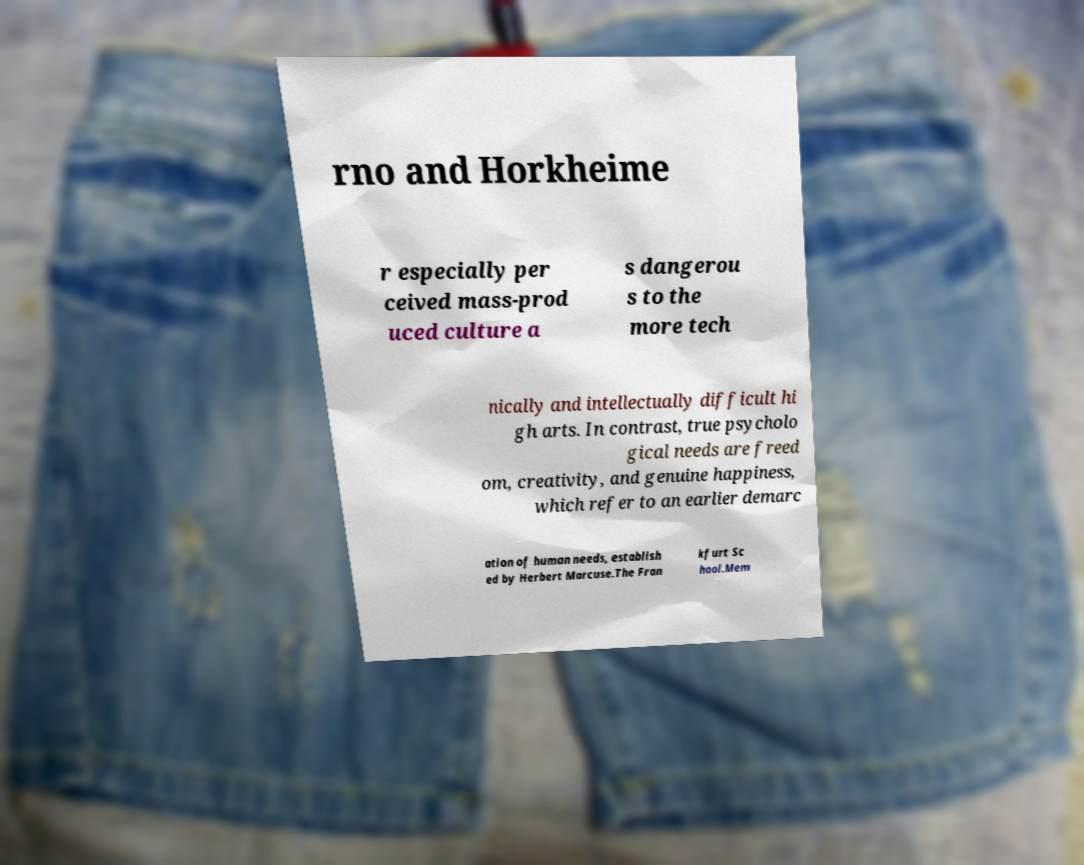There's text embedded in this image that I need extracted. Can you transcribe it verbatim? rno and Horkheime r especially per ceived mass-prod uced culture a s dangerou s to the more tech nically and intellectually difficult hi gh arts. In contrast, true psycholo gical needs are freed om, creativity, and genuine happiness, which refer to an earlier demarc ation of human needs, establish ed by Herbert Marcuse.The Fran kfurt Sc hool.Mem 